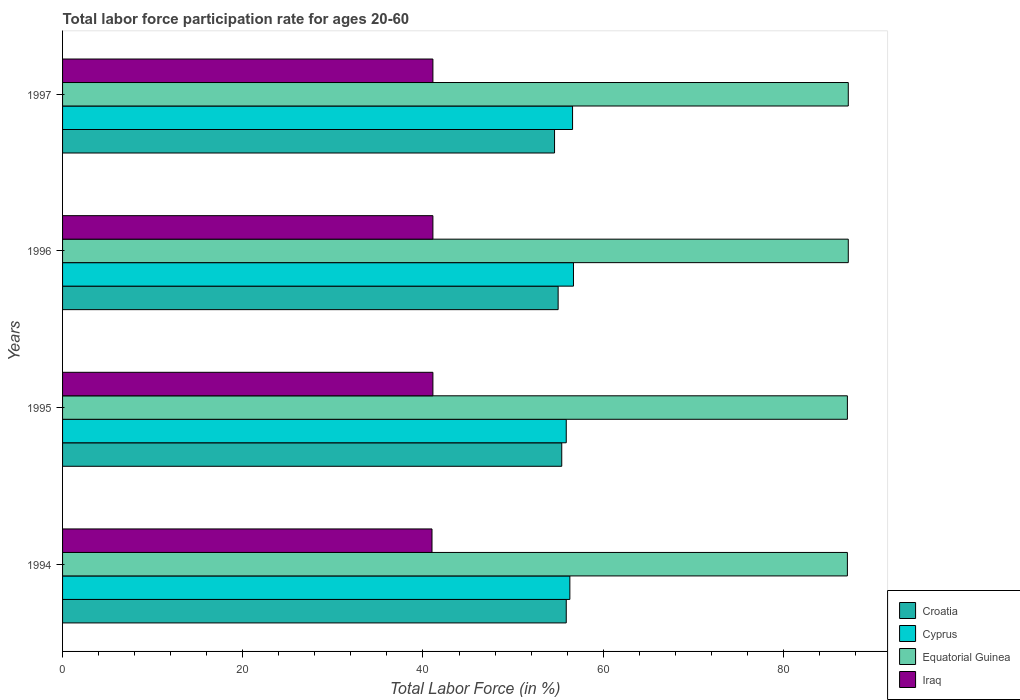How many groups of bars are there?
Provide a succinct answer. 4. How many bars are there on the 2nd tick from the bottom?
Offer a terse response. 4. What is the label of the 1st group of bars from the top?
Provide a succinct answer. 1997. In how many cases, is the number of bars for a given year not equal to the number of legend labels?
Make the answer very short. 0. What is the labor force participation rate in Iraq in 1997?
Provide a succinct answer. 41.1. Across all years, what is the maximum labor force participation rate in Iraq?
Keep it short and to the point. 41.1. Across all years, what is the minimum labor force participation rate in Iraq?
Offer a very short reply. 41. What is the total labor force participation rate in Cyprus in the graph?
Your answer should be compact. 225.5. What is the difference between the labor force participation rate in Iraq in 1997 and the labor force participation rate in Croatia in 1995?
Make the answer very short. -14.3. What is the average labor force participation rate in Cyprus per year?
Offer a terse response. 56.38. In the year 1995, what is the difference between the labor force participation rate in Cyprus and labor force participation rate in Iraq?
Your answer should be compact. 14.8. In how many years, is the labor force participation rate in Cyprus greater than 28 %?
Offer a terse response. 4. What is the ratio of the labor force participation rate in Croatia in 1995 to that in 1997?
Give a very brief answer. 1.01. Is the difference between the labor force participation rate in Cyprus in 1994 and 1996 greater than the difference between the labor force participation rate in Iraq in 1994 and 1996?
Give a very brief answer. No. What is the difference between the highest and the second highest labor force participation rate in Croatia?
Your response must be concise. 0.5. What is the difference between the highest and the lowest labor force participation rate in Croatia?
Offer a terse response. 1.3. What does the 2nd bar from the top in 1996 represents?
Offer a terse response. Equatorial Guinea. What does the 3rd bar from the bottom in 1996 represents?
Your answer should be very brief. Equatorial Guinea. Is it the case that in every year, the sum of the labor force participation rate in Croatia and labor force participation rate in Iraq is greater than the labor force participation rate in Equatorial Guinea?
Provide a short and direct response. Yes. How many bars are there?
Ensure brevity in your answer.  16. How many years are there in the graph?
Offer a terse response. 4. Are the values on the major ticks of X-axis written in scientific E-notation?
Your response must be concise. No. Does the graph contain any zero values?
Keep it short and to the point. No. Does the graph contain grids?
Provide a succinct answer. No. How many legend labels are there?
Make the answer very short. 4. What is the title of the graph?
Your answer should be very brief. Total labor force participation rate for ages 20-60. What is the label or title of the Y-axis?
Offer a terse response. Years. What is the Total Labor Force (in %) in Croatia in 1994?
Keep it short and to the point. 55.9. What is the Total Labor Force (in %) in Cyprus in 1994?
Offer a very short reply. 56.3. What is the Total Labor Force (in %) of Equatorial Guinea in 1994?
Keep it short and to the point. 87.1. What is the Total Labor Force (in %) of Croatia in 1995?
Your answer should be compact. 55.4. What is the Total Labor Force (in %) in Cyprus in 1995?
Keep it short and to the point. 55.9. What is the Total Labor Force (in %) of Equatorial Guinea in 1995?
Ensure brevity in your answer.  87.1. What is the Total Labor Force (in %) in Iraq in 1995?
Your response must be concise. 41.1. What is the Total Labor Force (in %) in Croatia in 1996?
Offer a terse response. 55. What is the Total Labor Force (in %) of Cyprus in 1996?
Your answer should be compact. 56.7. What is the Total Labor Force (in %) in Equatorial Guinea in 1996?
Provide a succinct answer. 87.2. What is the Total Labor Force (in %) of Iraq in 1996?
Keep it short and to the point. 41.1. What is the Total Labor Force (in %) of Croatia in 1997?
Your answer should be compact. 54.6. What is the Total Labor Force (in %) in Cyprus in 1997?
Keep it short and to the point. 56.6. What is the Total Labor Force (in %) of Equatorial Guinea in 1997?
Make the answer very short. 87.2. What is the Total Labor Force (in %) of Iraq in 1997?
Provide a short and direct response. 41.1. Across all years, what is the maximum Total Labor Force (in %) in Croatia?
Ensure brevity in your answer.  55.9. Across all years, what is the maximum Total Labor Force (in %) in Cyprus?
Your answer should be very brief. 56.7. Across all years, what is the maximum Total Labor Force (in %) of Equatorial Guinea?
Offer a very short reply. 87.2. Across all years, what is the maximum Total Labor Force (in %) of Iraq?
Give a very brief answer. 41.1. Across all years, what is the minimum Total Labor Force (in %) in Croatia?
Keep it short and to the point. 54.6. Across all years, what is the minimum Total Labor Force (in %) of Cyprus?
Your answer should be very brief. 55.9. Across all years, what is the minimum Total Labor Force (in %) of Equatorial Guinea?
Offer a very short reply. 87.1. Across all years, what is the minimum Total Labor Force (in %) in Iraq?
Ensure brevity in your answer.  41. What is the total Total Labor Force (in %) in Croatia in the graph?
Your answer should be compact. 220.9. What is the total Total Labor Force (in %) of Cyprus in the graph?
Offer a very short reply. 225.5. What is the total Total Labor Force (in %) of Equatorial Guinea in the graph?
Keep it short and to the point. 348.6. What is the total Total Labor Force (in %) of Iraq in the graph?
Your response must be concise. 164.3. What is the difference between the Total Labor Force (in %) of Croatia in 1994 and that in 1995?
Ensure brevity in your answer.  0.5. What is the difference between the Total Labor Force (in %) in Equatorial Guinea in 1994 and that in 1995?
Keep it short and to the point. 0. What is the difference between the Total Labor Force (in %) in Cyprus in 1994 and that in 1997?
Ensure brevity in your answer.  -0.3. What is the difference between the Total Labor Force (in %) of Equatorial Guinea in 1994 and that in 1997?
Provide a succinct answer. -0.1. What is the difference between the Total Labor Force (in %) in Croatia in 1995 and that in 1996?
Ensure brevity in your answer.  0.4. What is the difference between the Total Labor Force (in %) in Equatorial Guinea in 1995 and that in 1996?
Provide a short and direct response. -0.1. What is the difference between the Total Labor Force (in %) in Equatorial Guinea in 1995 and that in 1997?
Make the answer very short. -0.1. What is the difference between the Total Labor Force (in %) of Cyprus in 1996 and that in 1997?
Your response must be concise. 0.1. What is the difference between the Total Labor Force (in %) in Equatorial Guinea in 1996 and that in 1997?
Give a very brief answer. 0. What is the difference between the Total Labor Force (in %) of Iraq in 1996 and that in 1997?
Give a very brief answer. 0. What is the difference between the Total Labor Force (in %) of Croatia in 1994 and the Total Labor Force (in %) of Equatorial Guinea in 1995?
Your response must be concise. -31.2. What is the difference between the Total Labor Force (in %) in Cyprus in 1994 and the Total Labor Force (in %) in Equatorial Guinea in 1995?
Provide a succinct answer. -30.8. What is the difference between the Total Labor Force (in %) of Equatorial Guinea in 1994 and the Total Labor Force (in %) of Iraq in 1995?
Your answer should be compact. 46. What is the difference between the Total Labor Force (in %) in Croatia in 1994 and the Total Labor Force (in %) in Cyprus in 1996?
Keep it short and to the point. -0.8. What is the difference between the Total Labor Force (in %) in Croatia in 1994 and the Total Labor Force (in %) in Equatorial Guinea in 1996?
Your answer should be compact. -31.3. What is the difference between the Total Labor Force (in %) in Croatia in 1994 and the Total Labor Force (in %) in Iraq in 1996?
Make the answer very short. 14.8. What is the difference between the Total Labor Force (in %) in Cyprus in 1994 and the Total Labor Force (in %) in Equatorial Guinea in 1996?
Your answer should be very brief. -30.9. What is the difference between the Total Labor Force (in %) in Cyprus in 1994 and the Total Labor Force (in %) in Iraq in 1996?
Provide a short and direct response. 15.2. What is the difference between the Total Labor Force (in %) in Equatorial Guinea in 1994 and the Total Labor Force (in %) in Iraq in 1996?
Give a very brief answer. 46. What is the difference between the Total Labor Force (in %) of Croatia in 1994 and the Total Labor Force (in %) of Cyprus in 1997?
Your response must be concise. -0.7. What is the difference between the Total Labor Force (in %) of Croatia in 1994 and the Total Labor Force (in %) of Equatorial Guinea in 1997?
Offer a terse response. -31.3. What is the difference between the Total Labor Force (in %) in Croatia in 1994 and the Total Labor Force (in %) in Iraq in 1997?
Keep it short and to the point. 14.8. What is the difference between the Total Labor Force (in %) of Cyprus in 1994 and the Total Labor Force (in %) of Equatorial Guinea in 1997?
Give a very brief answer. -30.9. What is the difference between the Total Labor Force (in %) of Croatia in 1995 and the Total Labor Force (in %) of Equatorial Guinea in 1996?
Your answer should be very brief. -31.8. What is the difference between the Total Labor Force (in %) of Croatia in 1995 and the Total Labor Force (in %) of Iraq in 1996?
Offer a very short reply. 14.3. What is the difference between the Total Labor Force (in %) of Cyprus in 1995 and the Total Labor Force (in %) of Equatorial Guinea in 1996?
Provide a short and direct response. -31.3. What is the difference between the Total Labor Force (in %) in Cyprus in 1995 and the Total Labor Force (in %) in Iraq in 1996?
Provide a succinct answer. 14.8. What is the difference between the Total Labor Force (in %) of Croatia in 1995 and the Total Labor Force (in %) of Cyprus in 1997?
Give a very brief answer. -1.2. What is the difference between the Total Labor Force (in %) in Croatia in 1995 and the Total Labor Force (in %) in Equatorial Guinea in 1997?
Your response must be concise. -31.8. What is the difference between the Total Labor Force (in %) of Croatia in 1995 and the Total Labor Force (in %) of Iraq in 1997?
Offer a terse response. 14.3. What is the difference between the Total Labor Force (in %) of Cyprus in 1995 and the Total Labor Force (in %) of Equatorial Guinea in 1997?
Provide a succinct answer. -31.3. What is the difference between the Total Labor Force (in %) in Cyprus in 1995 and the Total Labor Force (in %) in Iraq in 1997?
Your answer should be very brief. 14.8. What is the difference between the Total Labor Force (in %) of Equatorial Guinea in 1995 and the Total Labor Force (in %) of Iraq in 1997?
Ensure brevity in your answer.  46. What is the difference between the Total Labor Force (in %) in Croatia in 1996 and the Total Labor Force (in %) in Cyprus in 1997?
Make the answer very short. -1.6. What is the difference between the Total Labor Force (in %) in Croatia in 1996 and the Total Labor Force (in %) in Equatorial Guinea in 1997?
Your answer should be compact. -32.2. What is the difference between the Total Labor Force (in %) in Croatia in 1996 and the Total Labor Force (in %) in Iraq in 1997?
Your answer should be very brief. 13.9. What is the difference between the Total Labor Force (in %) of Cyprus in 1996 and the Total Labor Force (in %) of Equatorial Guinea in 1997?
Give a very brief answer. -30.5. What is the difference between the Total Labor Force (in %) in Equatorial Guinea in 1996 and the Total Labor Force (in %) in Iraq in 1997?
Keep it short and to the point. 46.1. What is the average Total Labor Force (in %) in Croatia per year?
Provide a succinct answer. 55.23. What is the average Total Labor Force (in %) of Cyprus per year?
Provide a succinct answer. 56.38. What is the average Total Labor Force (in %) of Equatorial Guinea per year?
Provide a succinct answer. 87.15. What is the average Total Labor Force (in %) of Iraq per year?
Make the answer very short. 41.08. In the year 1994, what is the difference between the Total Labor Force (in %) in Croatia and Total Labor Force (in %) in Cyprus?
Make the answer very short. -0.4. In the year 1994, what is the difference between the Total Labor Force (in %) in Croatia and Total Labor Force (in %) in Equatorial Guinea?
Keep it short and to the point. -31.2. In the year 1994, what is the difference between the Total Labor Force (in %) in Croatia and Total Labor Force (in %) in Iraq?
Offer a very short reply. 14.9. In the year 1994, what is the difference between the Total Labor Force (in %) of Cyprus and Total Labor Force (in %) of Equatorial Guinea?
Your answer should be very brief. -30.8. In the year 1994, what is the difference between the Total Labor Force (in %) in Equatorial Guinea and Total Labor Force (in %) in Iraq?
Offer a terse response. 46.1. In the year 1995, what is the difference between the Total Labor Force (in %) of Croatia and Total Labor Force (in %) of Equatorial Guinea?
Offer a terse response. -31.7. In the year 1995, what is the difference between the Total Labor Force (in %) in Croatia and Total Labor Force (in %) in Iraq?
Your answer should be very brief. 14.3. In the year 1995, what is the difference between the Total Labor Force (in %) in Cyprus and Total Labor Force (in %) in Equatorial Guinea?
Your answer should be very brief. -31.2. In the year 1996, what is the difference between the Total Labor Force (in %) in Croatia and Total Labor Force (in %) in Cyprus?
Ensure brevity in your answer.  -1.7. In the year 1996, what is the difference between the Total Labor Force (in %) of Croatia and Total Labor Force (in %) of Equatorial Guinea?
Your response must be concise. -32.2. In the year 1996, what is the difference between the Total Labor Force (in %) of Cyprus and Total Labor Force (in %) of Equatorial Guinea?
Keep it short and to the point. -30.5. In the year 1996, what is the difference between the Total Labor Force (in %) in Cyprus and Total Labor Force (in %) in Iraq?
Give a very brief answer. 15.6. In the year 1996, what is the difference between the Total Labor Force (in %) in Equatorial Guinea and Total Labor Force (in %) in Iraq?
Your answer should be very brief. 46.1. In the year 1997, what is the difference between the Total Labor Force (in %) in Croatia and Total Labor Force (in %) in Cyprus?
Provide a succinct answer. -2. In the year 1997, what is the difference between the Total Labor Force (in %) of Croatia and Total Labor Force (in %) of Equatorial Guinea?
Give a very brief answer. -32.6. In the year 1997, what is the difference between the Total Labor Force (in %) of Cyprus and Total Labor Force (in %) of Equatorial Guinea?
Your answer should be compact. -30.6. In the year 1997, what is the difference between the Total Labor Force (in %) of Equatorial Guinea and Total Labor Force (in %) of Iraq?
Your response must be concise. 46.1. What is the ratio of the Total Labor Force (in %) in Cyprus in 1994 to that in 1995?
Offer a terse response. 1.01. What is the ratio of the Total Labor Force (in %) in Equatorial Guinea in 1994 to that in 1995?
Your answer should be very brief. 1. What is the ratio of the Total Labor Force (in %) of Croatia in 1994 to that in 1996?
Your answer should be compact. 1.02. What is the ratio of the Total Labor Force (in %) in Equatorial Guinea in 1994 to that in 1996?
Your answer should be very brief. 1. What is the ratio of the Total Labor Force (in %) of Croatia in 1994 to that in 1997?
Offer a very short reply. 1.02. What is the ratio of the Total Labor Force (in %) in Equatorial Guinea in 1994 to that in 1997?
Provide a short and direct response. 1. What is the ratio of the Total Labor Force (in %) of Croatia in 1995 to that in 1996?
Provide a succinct answer. 1.01. What is the ratio of the Total Labor Force (in %) in Cyprus in 1995 to that in 1996?
Your answer should be compact. 0.99. What is the ratio of the Total Labor Force (in %) of Equatorial Guinea in 1995 to that in 1996?
Your answer should be compact. 1. What is the ratio of the Total Labor Force (in %) in Croatia in 1995 to that in 1997?
Offer a terse response. 1.01. What is the ratio of the Total Labor Force (in %) of Cyprus in 1995 to that in 1997?
Make the answer very short. 0.99. What is the ratio of the Total Labor Force (in %) of Equatorial Guinea in 1995 to that in 1997?
Offer a very short reply. 1. What is the ratio of the Total Labor Force (in %) in Croatia in 1996 to that in 1997?
Your response must be concise. 1.01. What is the ratio of the Total Labor Force (in %) in Cyprus in 1996 to that in 1997?
Give a very brief answer. 1. What is the ratio of the Total Labor Force (in %) of Iraq in 1996 to that in 1997?
Offer a very short reply. 1. What is the difference between the highest and the second highest Total Labor Force (in %) of Cyprus?
Keep it short and to the point. 0.1. What is the difference between the highest and the second highest Total Labor Force (in %) in Equatorial Guinea?
Your answer should be compact. 0. What is the difference between the highest and the lowest Total Labor Force (in %) of Equatorial Guinea?
Keep it short and to the point. 0.1. What is the difference between the highest and the lowest Total Labor Force (in %) of Iraq?
Keep it short and to the point. 0.1. 